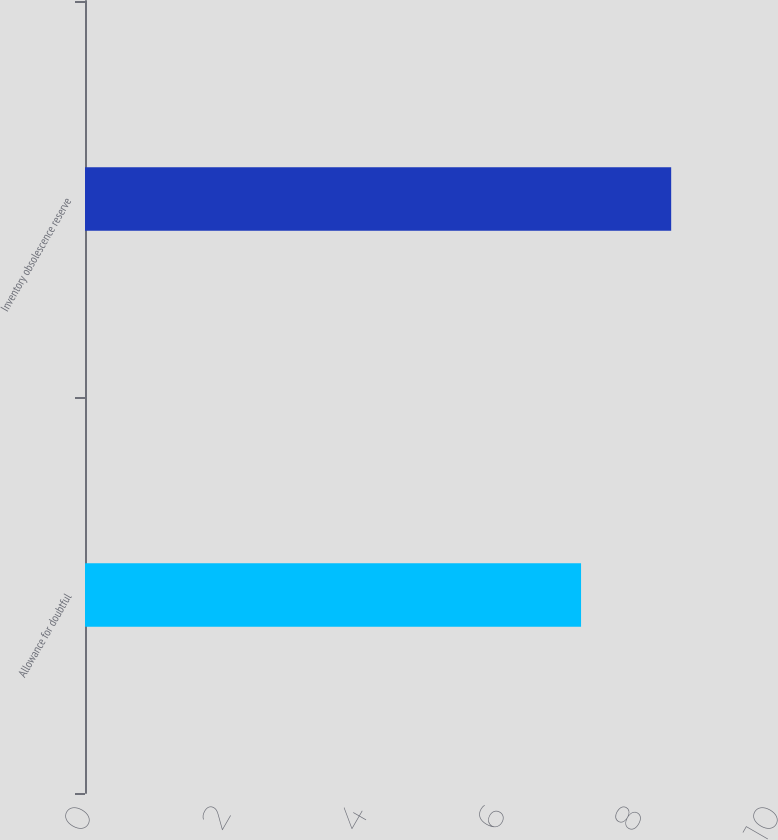Convert chart to OTSL. <chart><loc_0><loc_0><loc_500><loc_500><bar_chart><fcel>Allowance for doubtful<fcel>Inventory obsolescence reserve<nl><fcel>7.21<fcel>8.52<nl></chart> 